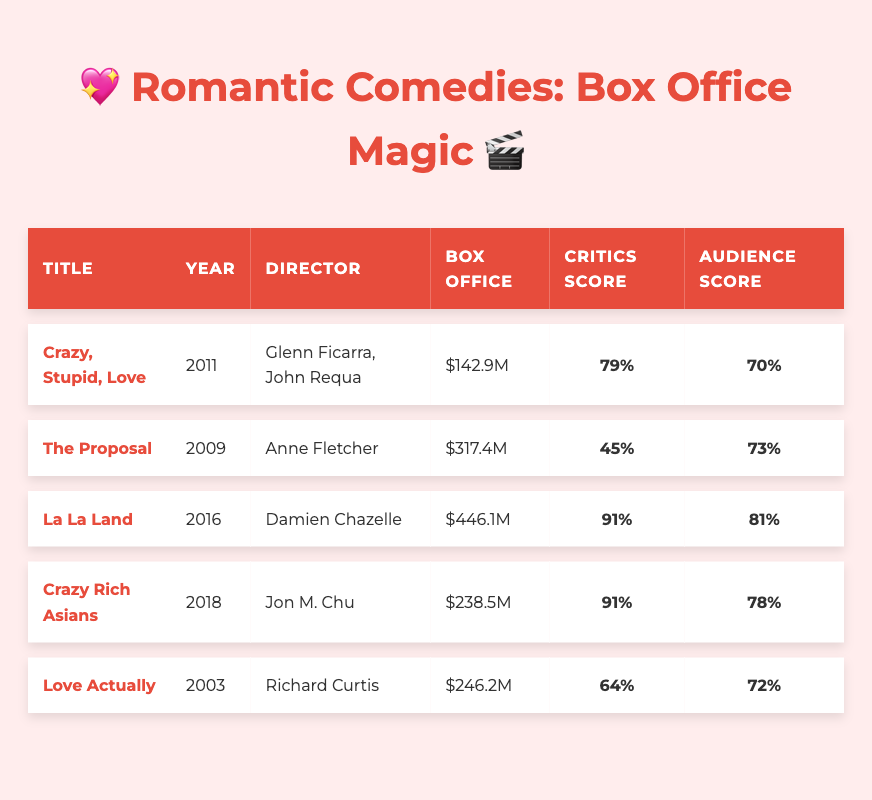What is the title of the movie with the highest box office gross? The table lists the box office grosses for each film. Comparing the values, "La La Land" has the highest gross of 446.1 million dollars.
Answer: La La Land Which movie received the highest critics score? Looking at the critics scores in the table, "La La Land" and "Crazy Rich Asians" both have scores of 91, which is the highest among all movies.
Answer: La La Land, Crazy Rich Asians What is the budget of "Crazy Rich Asians"? The table shows the budget for "Crazy Rich Asians" as 30 million dollars.
Answer: 30 million dollars Calculate the average audience score for all movies listed in the table. The audience scores are 70, 73, 81, 78, 72. The sum is 74 + 73 + 81 + 78 + 72 = 374. Then, dividing by the number of movies (5), we get 374/5 = 74.8.
Answer: 74.8 Is "The Ugly Truth" more successful at the box office than "Crazy Stupid Love"? According to the table, "The Ugly Truth" grossed 88.6 million and "Crazy Stupid Love" grossed 142.9 million. Since 88.6 < 142.9, "The Ugly Truth" did not perform better.
Answer: No Which cast member appeared in both "Crazy, Stupid, Love" and "La La Land"? By examining the cast lists, Ryan Gosling is listed for both "Crazy, Stupid, Love" and "La La Land."
Answer: Ryan Gosling How much more did "The Proposal" earn compared to "The Ugly Truth"? "The Proposal" earned 317.4 million, while "The Ugly Truth" earned 88.6 million. The difference is calculated as 317.4 - 88.6 = 228.8 million.
Answer: 228.8 million Name a movie from the table released after 2015 with a box office gross over 200 million. After checking the release years and grosses, “Crazy Rich Asians” (2018) grossed 238.5 million, meeting the criteria.
Answer: Crazy Rich Asians What percentage of the audience rated "The Proposal" positively? The audience score for "The Proposal" is 73%, which indicates that 73% rated it positively.
Answer: 73% Is "Notting Hill" mentioned in the table? Upon reviewing the table, "Notting Hill" is not present among the list of movies.
Answer: No 